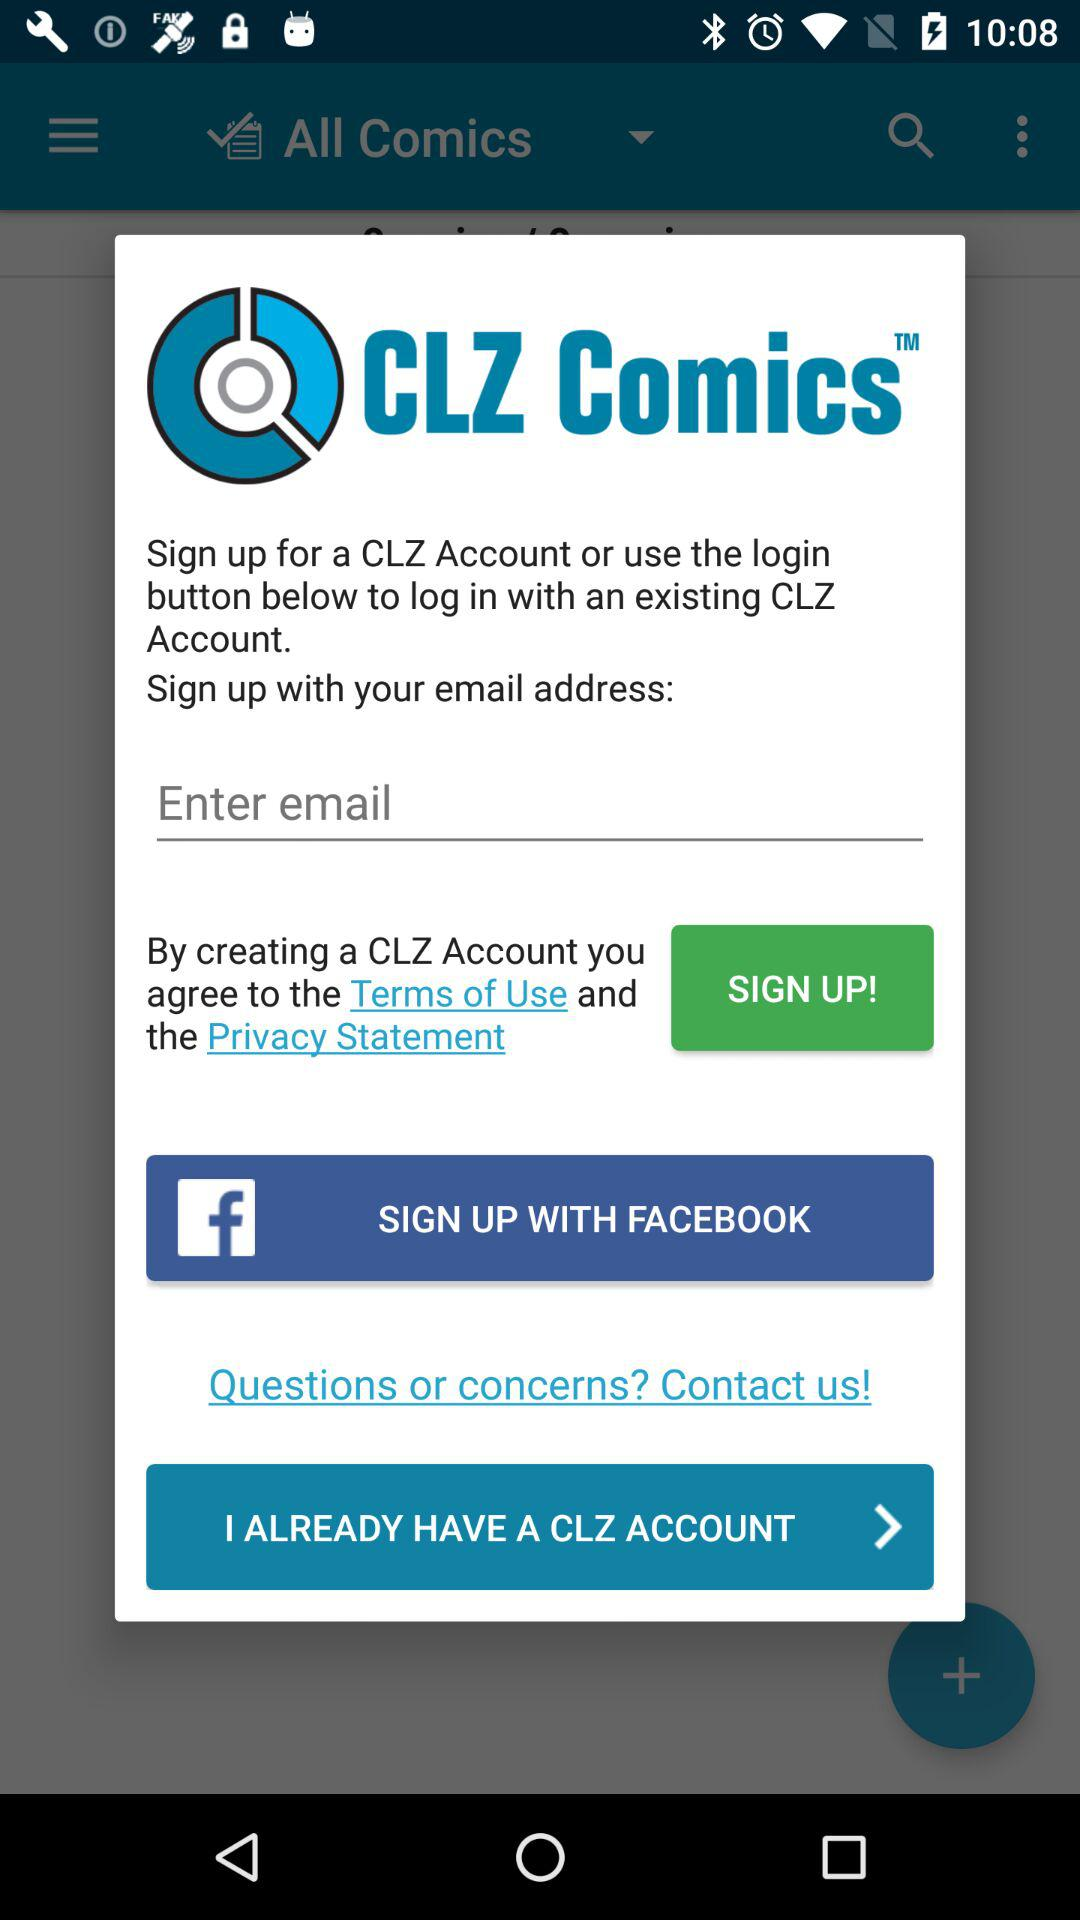What is the name of the application? The name of the application is "CLZ Comics". 